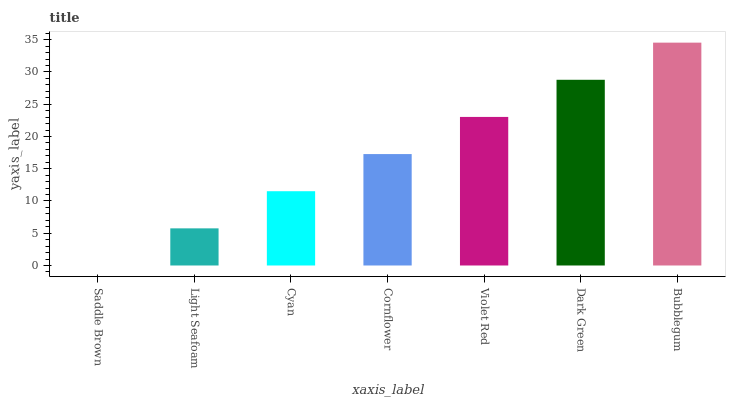Is Saddle Brown the minimum?
Answer yes or no. Yes. Is Bubblegum the maximum?
Answer yes or no. Yes. Is Light Seafoam the minimum?
Answer yes or no. No. Is Light Seafoam the maximum?
Answer yes or no. No. Is Light Seafoam greater than Saddle Brown?
Answer yes or no. Yes. Is Saddle Brown less than Light Seafoam?
Answer yes or no. Yes. Is Saddle Brown greater than Light Seafoam?
Answer yes or no. No. Is Light Seafoam less than Saddle Brown?
Answer yes or no. No. Is Cornflower the high median?
Answer yes or no. Yes. Is Cornflower the low median?
Answer yes or no. Yes. Is Cyan the high median?
Answer yes or no. No. Is Light Seafoam the low median?
Answer yes or no. No. 